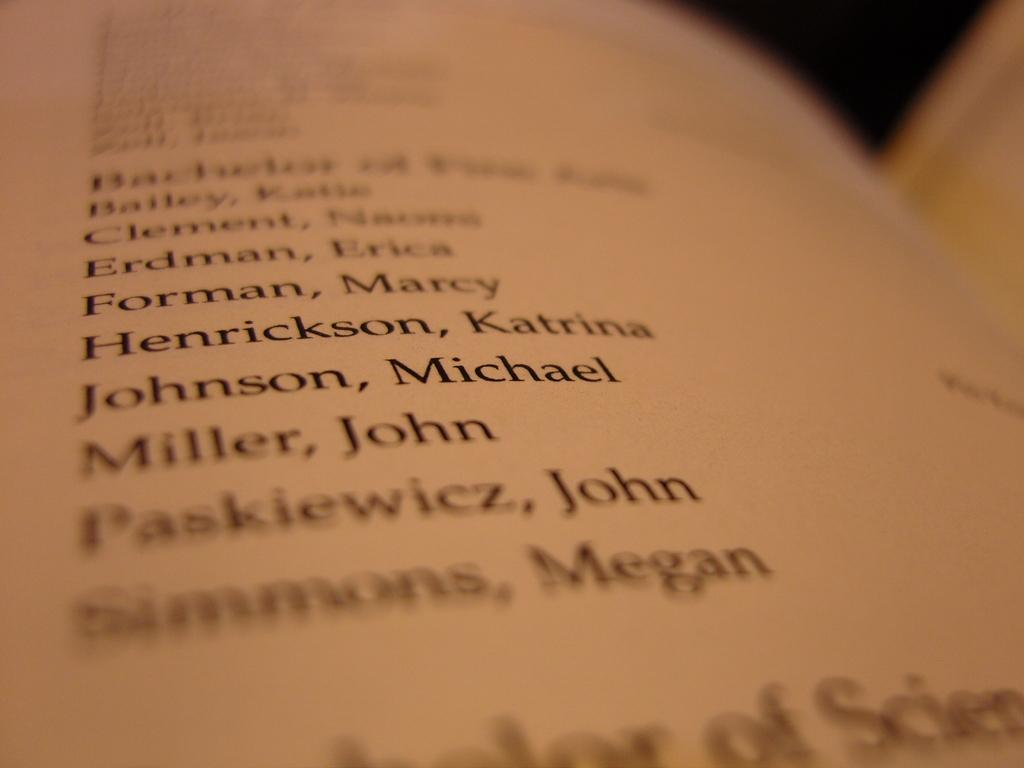What is the main subject of the image? The main subject of the image is a script written in a book. Can you describe the content of the script? Unfortunately, the content of the script cannot be determined from the image alone. What is the format of the script? The script appears to be written in a book, which suggests it is in a traditional, bound format. How many times does the person in the image kick the ball? There is no person or ball present in the image; it only features a script written in a book. 